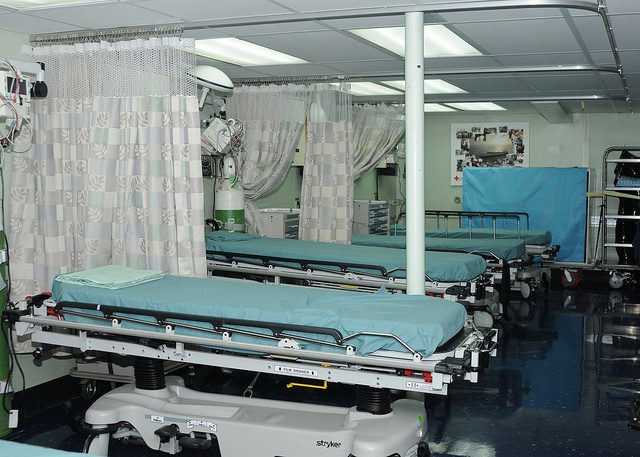Describe the objects in this image and their specific colors. I can see bed in beige, darkgray, lightblue, and black tones, bed in beige, teal, black, and darkgray tones, bed in beige and teal tones, and bed in beige, teal, and black tones in this image. 